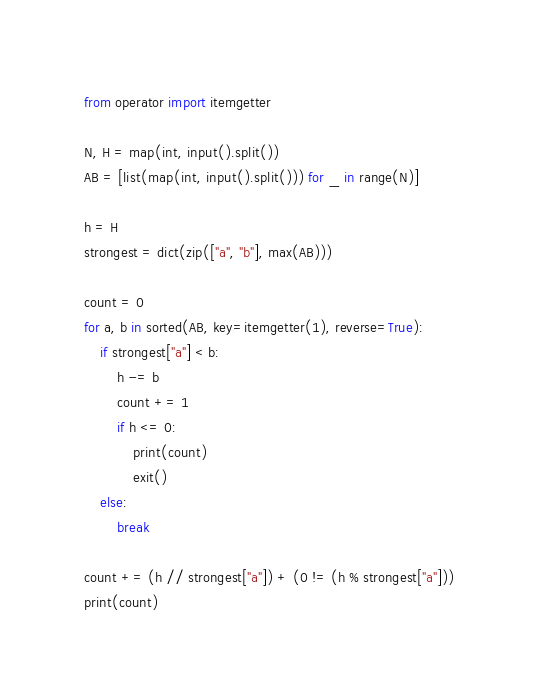<code> <loc_0><loc_0><loc_500><loc_500><_Python_>from operator import itemgetter

N, H = map(int, input().split())
AB = [list(map(int, input().split())) for _ in range(N)]

h = H
strongest = dict(zip(["a", "b"], max(AB)))

count = 0
for a, b in sorted(AB, key=itemgetter(1), reverse=True):
	if strongest["a"] < b:
		h -= b
		count += 1
		if h <= 0:
			print(count)
			exit()
	else:
		break

count += (h // strongest["a"]) + (0 != (h % strongest["a"]))
print(count)
</code> 